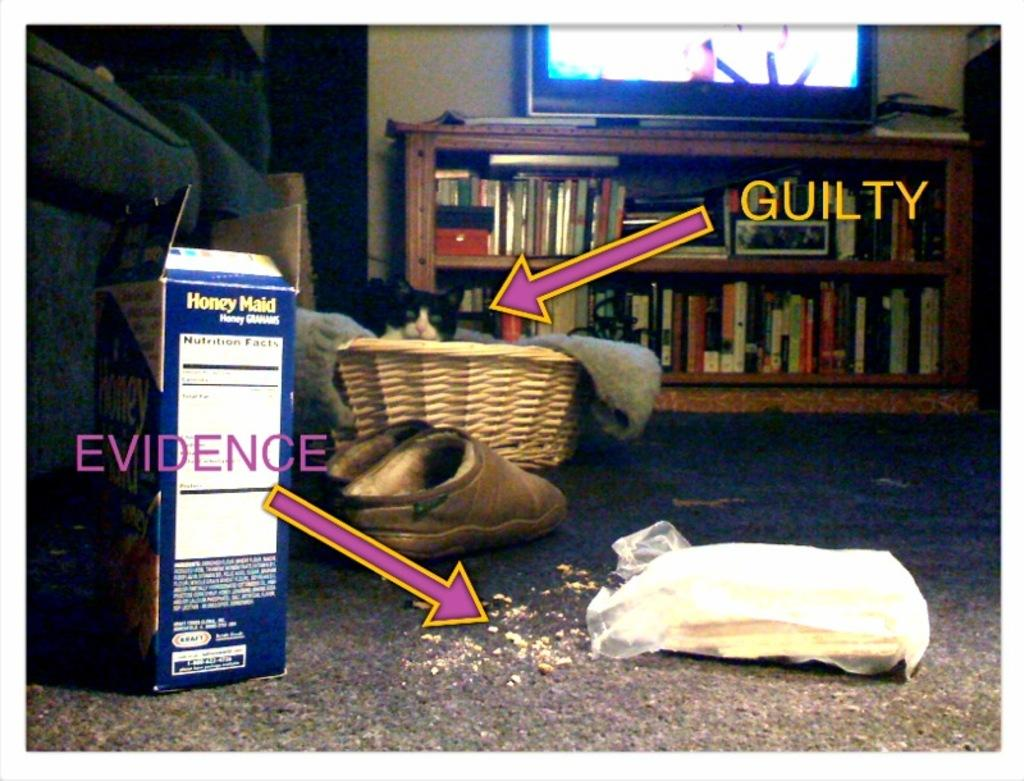<image>
Create a compact narrative representing the image presented. A box of Honey Maid is spilled on the carpet. 